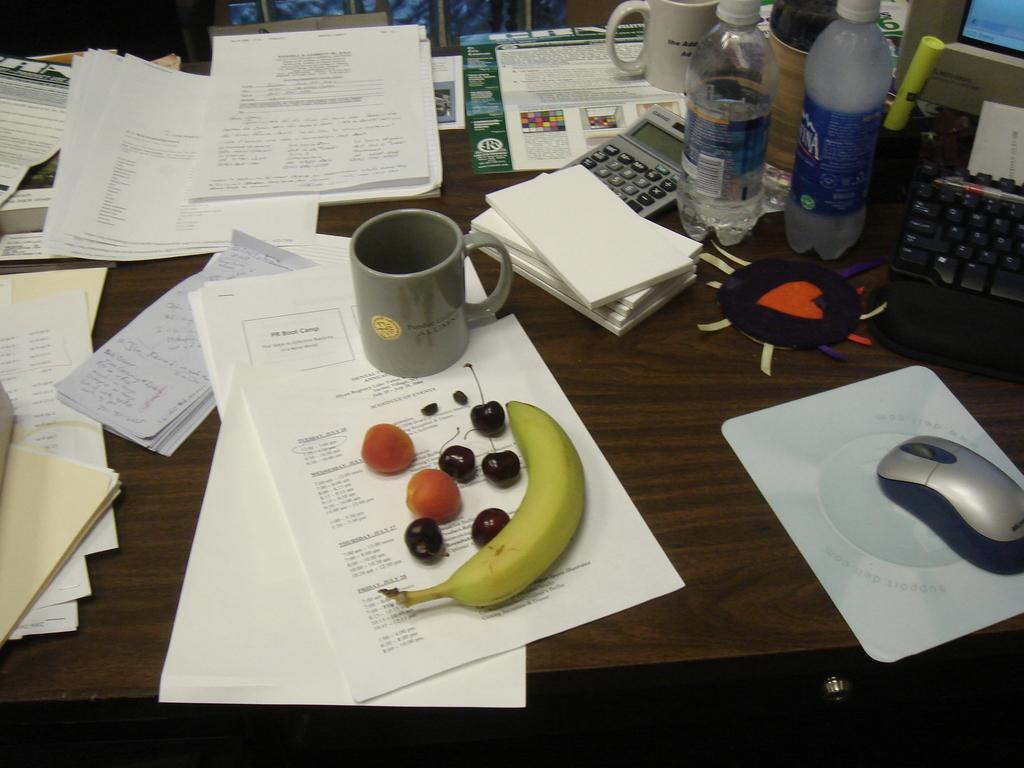Describe this image in one or two sentences. In this picture, we see papers, cup, banana and fruits, book, calculator, water bottle, mouse, mouse pad, keyboard and monitor are placed on brown table. 